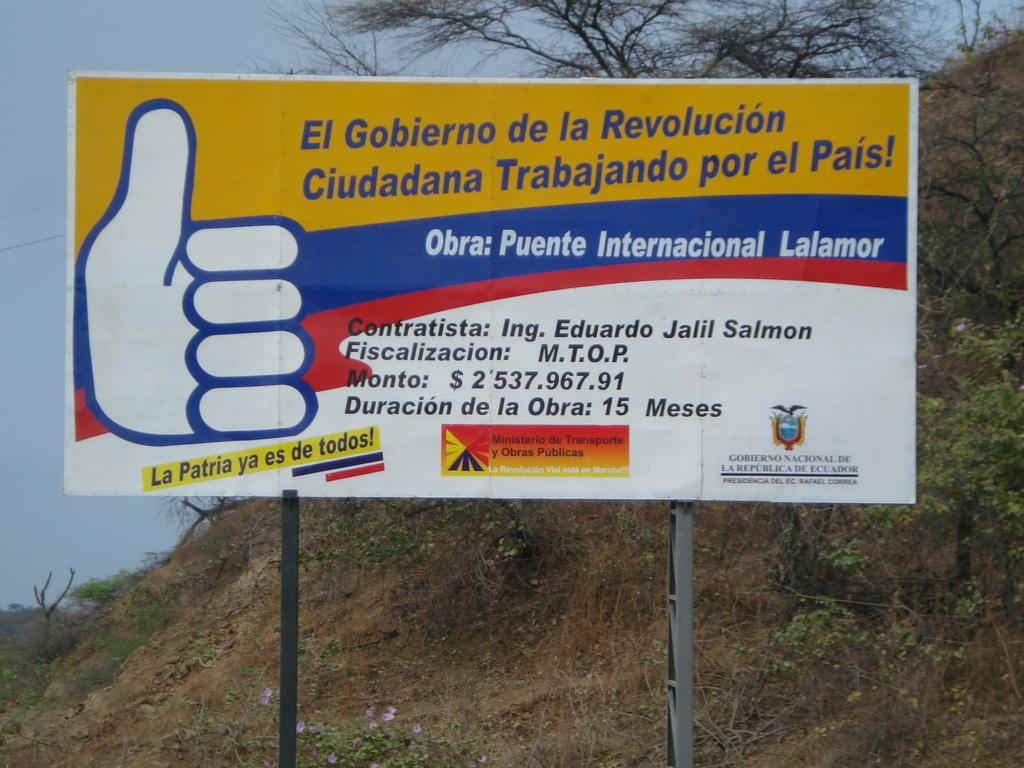Provide a one-sentence caption for the provided image. A large billboard has a thumbs up and says Obro: Puente Internacional Lalamor. 